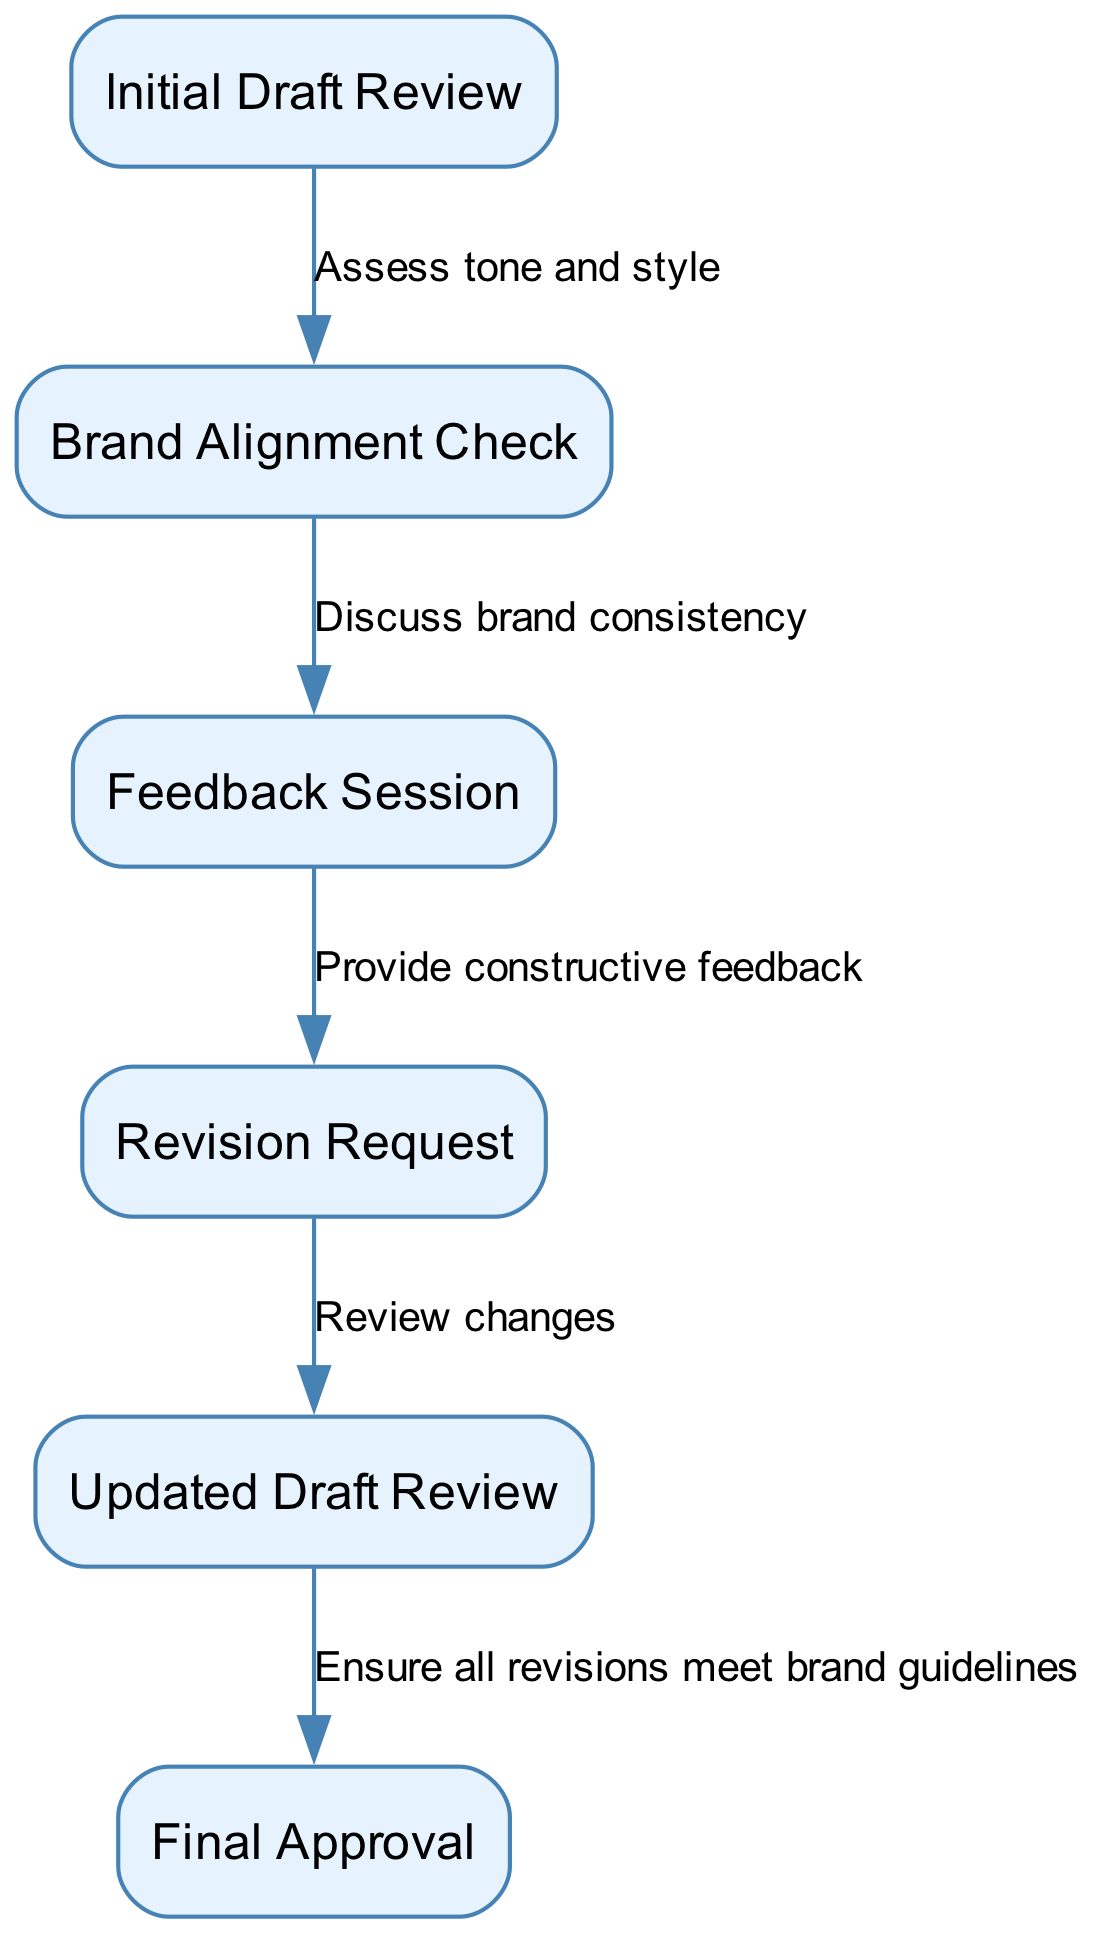What is the first stage in the creative feedback process? The diagram indicates that the first stage is "Initial Draft Review." This is clearly labeled as the starting point of the process.
Answer: Initial Draft Review How many nodes are in the diagram? By counting the entries listed under the "nodes" section of the data, we can see that there are a total of six nodes.
Answer: 6 What is the last stage before final approval? The diagram shows that the last stage before "Final Approval" is "Updated Draft Review." This is the node immediately prior to the final step, according to the flow.
Answer: Updated Draft Review Which stage involves assessing tone and style? The flow from the "Initial Draft Review" to "Brand Alignment Check" indicates that this is where tone and style are assessed. The edge explicitly states this relationship.
Answer: Assess tone and style What is the relationship between feedback session and revision request? The diagram indicates that after the "Feedback Session," there is a direct flow to "Revision Request," which involves providing constructive feedback, as shown by the labeled edge connecting the two nodes.
Answer: Provide constructive feedback What comes before the "Final Approval"? The diagram indicates that "Updated Draft Review" is the preceding stage before the final approval, as it is the last stage in the flow leading to "Final Approval."
Answer: Updated Draft Review How many edges are connecting the nodes in the diagram? By reviewing the connections under the "edges" section, we find that there are five edges that connect the six nodes in the diagram, demonstrating the flow of the feedback process.
Answer: 5 Which two stages discuss brand consistency? The flow from "Brand Alignment Check" to "Feedback Session" shows this discussion, as the edge explicitly labels it as part of the discussion process regarding brand consistency.
Answer: Discuss brand consistency Which node directly follows the revision request? The diagram flows from "Revision Request" to "Updated Draft Review," indicating that this is the next stage that follows the revision stage.
Answer: Updated Draft Review 